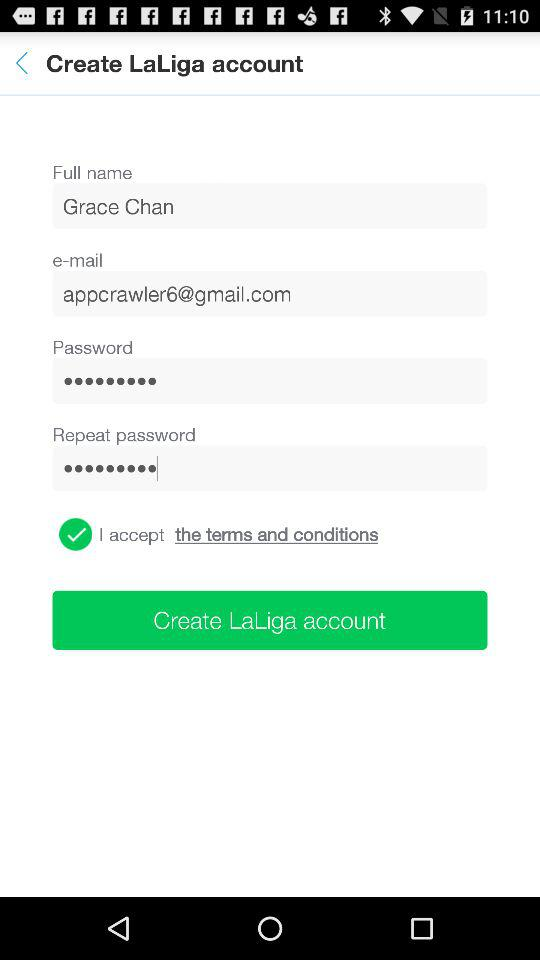What is the email address? The email address is appcrawler6@gmail.com. 